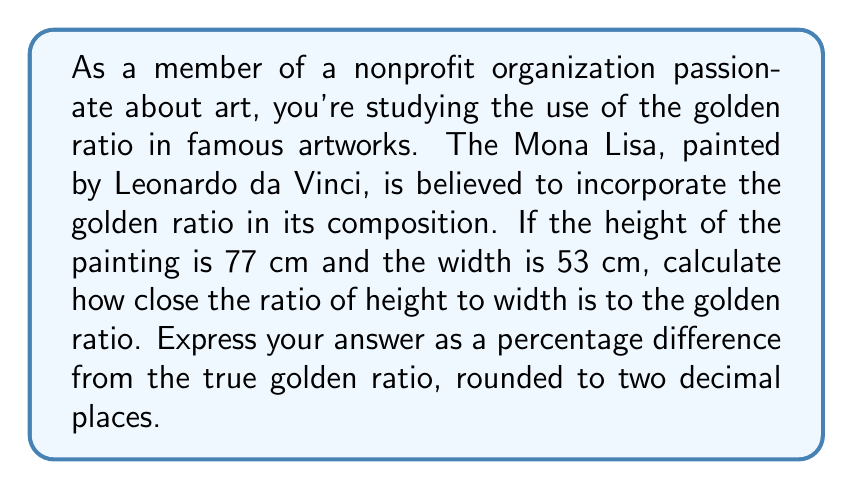Give your solution to this math problem. To solve this problem, we'll follow these steps:

1) First, let's recall the definition of the golden ratio, often denoted by $\phi$ (phi):

   $$\phi = \frac{1 + \sqrt{5}}{2} \approx 1.618033989$$

2) Now, let's calculate the ratio of the height to width of the Mona Lisa:

   $$\text{Ratio} = \frac{\text{Height}}{\text{Width}} = \frac{77 \text{ cm}}{53 \text{ cm}} \approx 1.452830189$$

3) To find the percentage difference, we use the formula:

   $$\text{Percentage Difference} = \left|\frac{\text{Observed Value} - \text{Expected Value}}{\text{Expected Value}}\right| \times 100\%$$

   Where the observed value is our calculated ratio, and the expected value is $\phi$.

4) Plugging in our values:

   $$\text{Percentage Difference} = \left|\frac{1.452830189 - 1.618033989}{1.618033989}\right| \times 100\%$$

5) Simplifying:

   $$\text{Percentage Difference} = 0.1020849 \times 100\% = 10.20849\%$$

6) Rounding to two decimal places:

   $$\text{Percentage Difference} \approx 10.21\%$$

This means the ratio of the Mona Lisa's dimensions differs from the golden ratio by approximately 10.21%.
Answer: 10.21% 